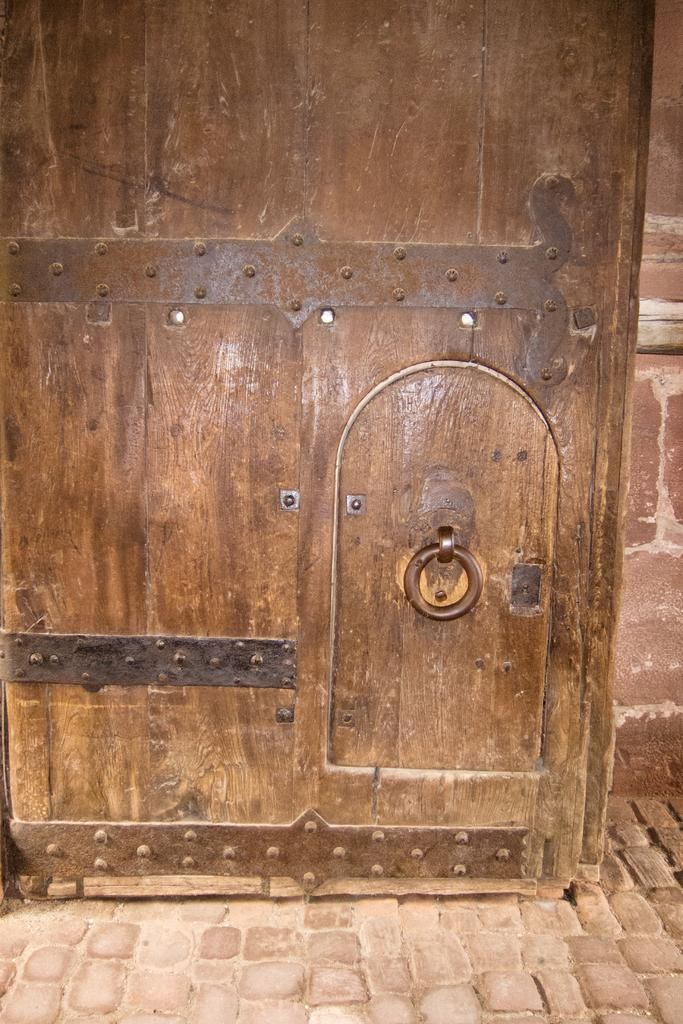What type of door is visible in the image? There is a wooden door in the image. What is behind the door in the image? There is a wall behind the door in the image. What can be seen at the bottom of the image? The floor is visible at the bottom of the image. What type of produce is hanging from the door in the image? There is no produce present in the image; it only features a wooden door, a wall, and the floor. 